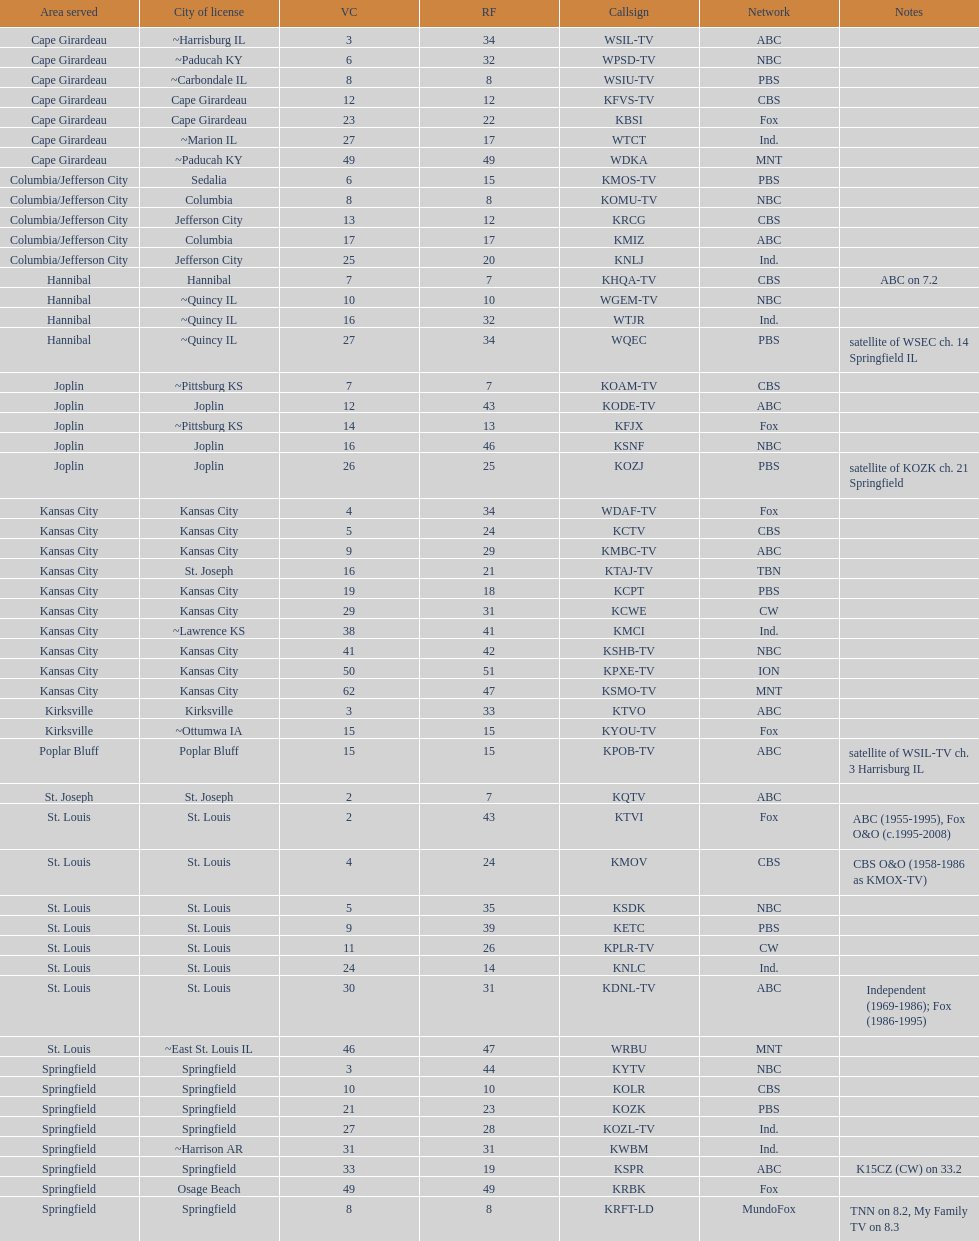What is the total number of stations serving the the cape girardeau area? 7. 